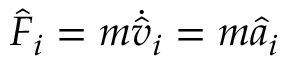<formula> <loc_0><loc_0><loc_500><loc_500>\hat { F } _ { i } = m \dot { \hat { v } } _ { i } = m \hat { a } _ { i }</formula> 